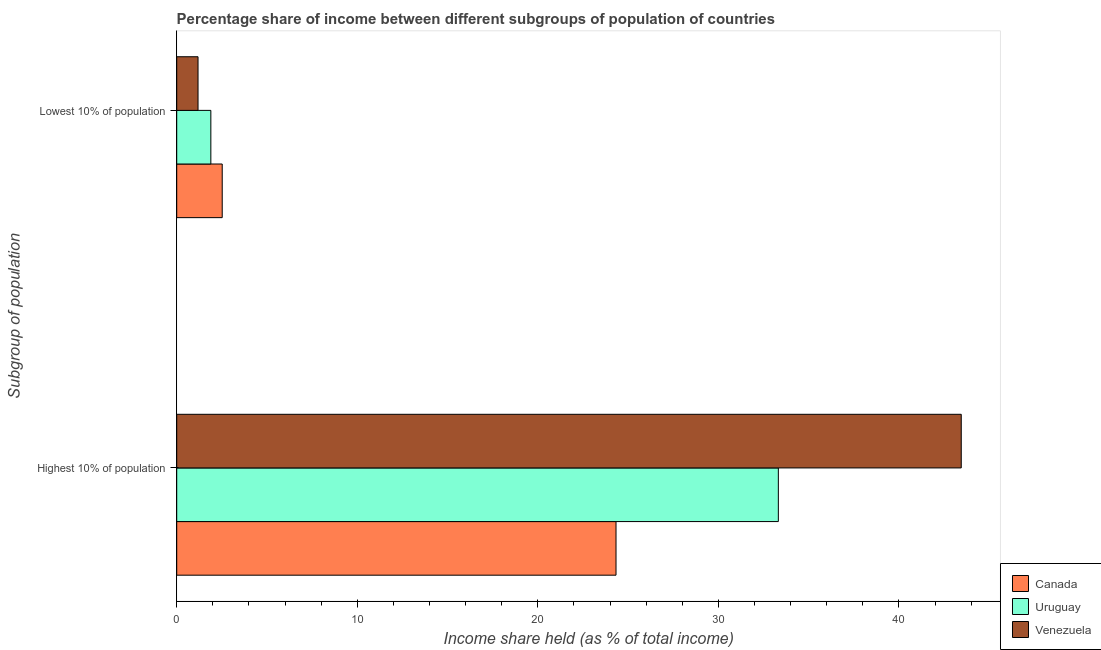How many groups of bars are there?
Your response must be concise. 2. Are the number of bars per tick equal to the number of legend labels?
Give a very brief answer. Yes. Are the number of bars on each tick of the Y-axis equal?
Your answer should be compact. Yes. What is the label of the 1st group of bars from the top?
Make the answer very short. Lowest 10% of population. What is the income share held by highest 10% of the population in Venezuela?
Give a very brief answer. 43.45. Across all countries, what is the maximum income share held by highest 10% of the population?
Your answer should be very brief. 43.45. Across all countries, what is the minimum income share held by highest 10% of the population?
Offer a very short reply. 24.33. In which country was the income share held by highest 10% of the population maximum?
Offer a very short reply. Venezuela. In which country was the income share held by lowest 10% of the population minimum?
Give a very brief answer. Venezuela. What is the total income share held by lowest 10% of the population in the graph?
Give a very brief answer. 5.59. What is the difference between the income share held by lowest 10% of the population in Canada and that in Uruguay?
Give a very brief answer. 0.63. What is the difference between the income share held by lowest 10% of the population in Uruguay and the income share held by highest 10% of the population in Canada?
Offer a terse response. -22.44. What is the average income share held by highest 10% of the population per country?
Your response must be concise. 33.7. What is the difference between the income share held by lowest 10% of the population and income share held by highest 10% of the population in Uruguay?
Keep it short and to the point. -31.43. In how many countries, is the income share held by highest 10% of the population greater than 20 %?
Your answer should be very brief. 3. What is the ratio of the income share held by highest 10% of the population in Venezuela to that in Uruguay?
Offer a very short reply. 1.3. Is the income share held by lowest 10% of the population in Venezuela less than that in Uruguay?
Give a very brief answer. Yes. In how many countries, is the income share held by lowest 10% of the population greater than the average income share held by lowest 10% of the population taken over all countries?
Offer a very short reply. 2. What does the 2nd bar from the top in Lowest 10% of population represents?
Ensure brevity in your answer.  Uruguay. How many bars are there?
Your answer should be very brief. 6. Are all the bars in the graph horizontal?
Provide a succinct answer. Yes. Does the graph contain any zero values?
Your response must be concise. No. Does the graph contain grids?
Your response must be concise. No. Where does the legend appear in the graph?
Offer a terse response. Bottom right. How many legend labels are there?
Your answer should be very brief. 3. How are the legend labels stacked?
Give a very brief answer. Vertical. What is the title of the graph?
Your response must be concise. Percentage share of income between different subgroups of population of countries. What is the label or title of the X-axis?
Give a very brief answer. Income share held (as % of total income). What is the label or title of the Y-axis?
Keep it short and to the point. Subgroup of population. What is the Income share held (as % of total income) in Canada in Highest 10% of population?
Offer a terse response. 24.33. What is the Income share held (as % of total income) of Uruguay in Highest 10% of population?
Your response must be concise. 33.32. What is the Income share held (as % of total income) of Venezuela in Highest 10% of population?
Make the answer very short. 43.45. What is the Income share held (as % of total income) in Canada in Lowest 10% of population?
Your answer should be compact. 2.52. What is the Income share held (as % of total income) in Uruguay in Lowest 10% of population?
Keep it short and to the point. 1.89. What is the Income share held (as % of total income) in Venezuela in Lowest 10% of population?
Your answer should be very brief. 1.18. Across all Subgroup of population, what is the maximum Income share held (as % of total income) of Canada?
Give a very brief answer. 24.33. Across all Subgroup of population, what is the maximum Income share held (as % of total income) in Uruguay?
Ensure brevity in your answer.  33.32. Across all Subgroup of population, what is the maximum Income share held (as % of total income) of Venezuela?
Provide a short and direct response. 43.45. Across all Subgroup of population, what is the minimum Income share held (as % of total income) of Canada?
Provide a succinct answer. 2.52. Across all Subgroup of population, what is the minimum Income share held (as % of total income) in Uruguay?
Offer a terse response. 1.89. Across all Subgroup of population, what is the minimum Income share held (as % of total income) of Venezuela?
Make the answer very short. 1.18. What is the total Income share held (as % of total income) of Canada in the graph?
Offer a very short reply. 26.85. What is the total Income share held (as % of total income) of Uruguay in the graph?
Ensure brevity in your answer.  35.21. What is the total Income share held (as % of total income) in Venezuela in the graph?
Offer a very short reply. 44.63. What is the difference between the Income share held (as % of total income) in Canada in Highest 10% of population and that in Lowest 10% of population?
Give a very brief answer. 21.81. What is the difference between the Income share held (as % of total income) in Uruguay in Highest 10% of population and that in Lowest 10% of population?
Your response must be concise. 31.43. What is the difference between the Income share held (as % of total income) of Venezuela in Highest 10% of population and that in Lowest 10% of population?
Offer a very short reply. 42.27. What is the difference between the Income share held (as % of total income) of Canada in Highest 10% of population and the Income share held (as % of total income) of Uruguay in Lowest 10% of population?
Give a very brief answer. 22.44. What is the difference between the Income share held (as % of total income) in Canada in Highest 10% of population and the Income share held (as % of total income) in Venezuela in Lowest 10% of population?
Your answer should be compact. 23.15. What is the difference between the Income share held (as % of total income) of Uruguay in Highest 10% of population and the Income share held (as % of total income) of Venezuela in Lowest 10% of population?
Your answer should be compact. 32.14. What is the average Income share held (as % of total income) in Canada per Subgroup of population?
Offer a terse response. 13.43. What is the average Income share held (as % of total income) of Uruguay per Subgroup of population?
Your response must be concise. 17.61. What is the average Income share held (as % of total income) in Venezuela per Subgroup of population?
Offer a terse response. 22.32. What is the difference between the Income share held (as % of total income) of Canada and Income share held (as % of total income) of Uruguay in Highest 10% of population?
Provide a succinct answer. -8.99. What is the difference between the Income share held (as % of total income) in Canada and Income share held (as % of total income) in Venezuela in Highest 10% of population?
Give a very brief answer. -19.12. What is the difference between the Income share held (as % of total income) in Uruguay and Income share held (as % of total income) in Venezuela in Highest 10% of population?
Make the answer very short. -10.13. What is the difference between the Income share held (as % of total income) of Canada and Income share held (as % of total income) of Uruguay in Lowest 10% of population?
Your answer should be very brief. 0.63. What is the difference between the Income share held (as % of total income) in Canada and Income share held (as % of total income) in Venezuela in Lowest 10% of population?
Your response must be concise. 1.34. What is the difference between the Income share held (as % of total income) of Uruguay and Income share held (as % of total income) of Venezuela in Lowest 10% of population?
Keep it short and to the point. 0.71. What is the ratio of the Income share held (as % of total income) of Canada in Highest 10% of population to that in Lowest 10% of population?
Provide a succinct answer. 9.65. What is the ratio of the Income share held (as % of total income) in Uruguay in Highest 10% of population to that in Lowest 10% of population?
Provide a succinct answer. 17.63. What is the ratio of the Income share held (as % of total income) in Venezuela in Highest 10% of population to that in Lowest 10% of population?
Your answer should be very brief. 36.82. What is the difference between the highest and the second highest Income share held (as % of total income) in Canada?
Your answer should be compact. 21.81. What is the difference between the highest and the second highest Income share held (as % of total income) of Uruguay?
Ensure brevity in your answer.  31.43. What is the difference between the highest and the second highest Income share held (as % of total income) of Venezuela?
Offer a terse response. 42.27. What is the difference between the highest and the lowest Income share held (as % of total income) in Canada?
Offer a terse response. 21.81. What is the difference between the highest and the lowest Income share held (as % of total income) of Uruguay?
Provide a short and direct response. 31.43. What is the difference between the highest and the lowest Income share held (as % of total income) in Venezuela?
Make the answer very short. 42.27. 